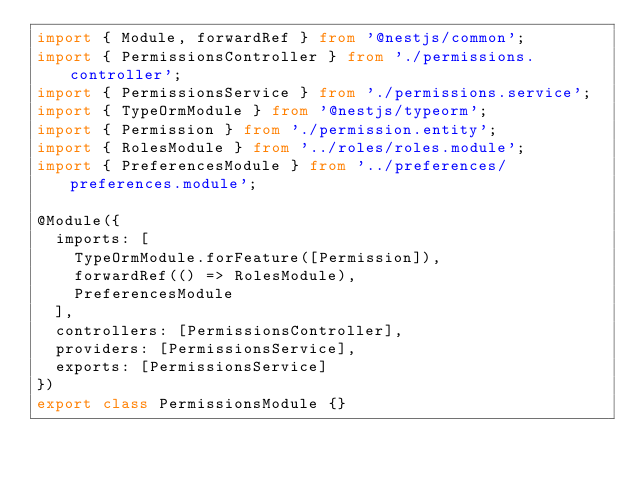Convert code to text. <code><loc_0><loc_0><loc_500><loc_500><_TypeScript_>import { Module, forwardRef } from '@nestjs/common';
import { PermissionsController } from './permissions.controller';
import { PermissionsService } from './permissions.service';
import { TypeOrmModule } from '@nestjs/typeorm';
import { Permission } from './permission.entity';
import { RolesModule } from '../roles/roles.module';
import { PreferencesModule } from '../preferences/preferences.module';

@Module({
  imports: [
    TypeOrmModule.forFeature([Permission]),
    forwardRef(() => RolesModule),
    PreferencesModule
  ],
  controllers: [PermissionsController],
  providers: [PermissionsService],
  exports: [PermissionsService]
})
export class PermissionsModule {}
</code> 